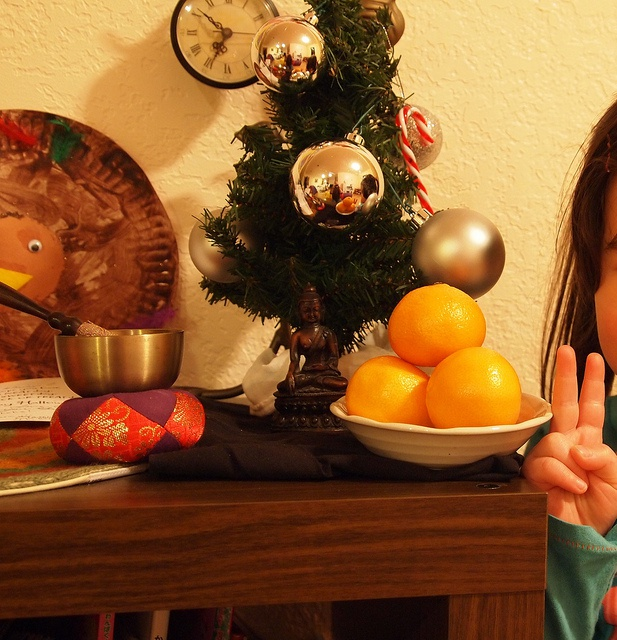Describe the objects in this image and their specific colors. I can see people in tan, black, orange, red, and maroon tones, bowl in tan, orange, red, brown, and gold tones, bowl in tan, maroon, and brown tones, orange in tan, orange, red, and gold tones, and clock in tan, orange, olive, and black tones in this image. 